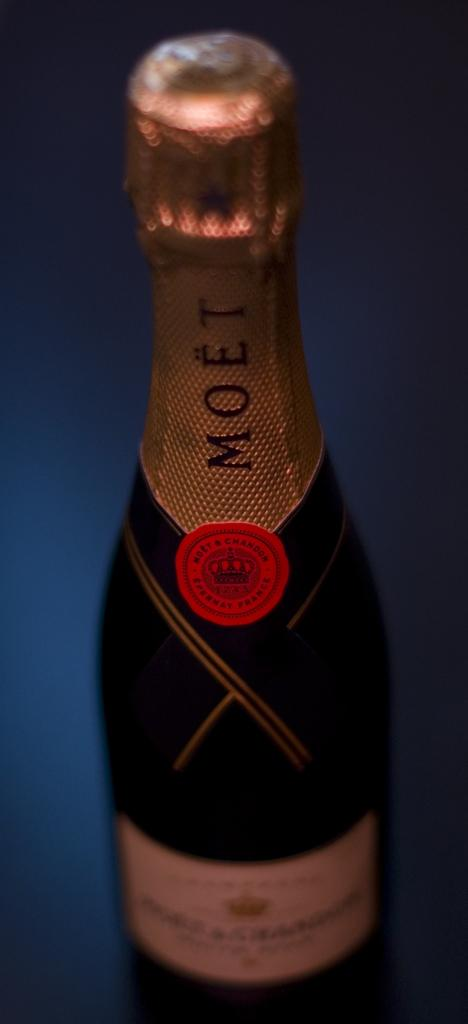<image>
Describe the image concisely. Moet & Chandon was established in Epernay, France, in 1743. 